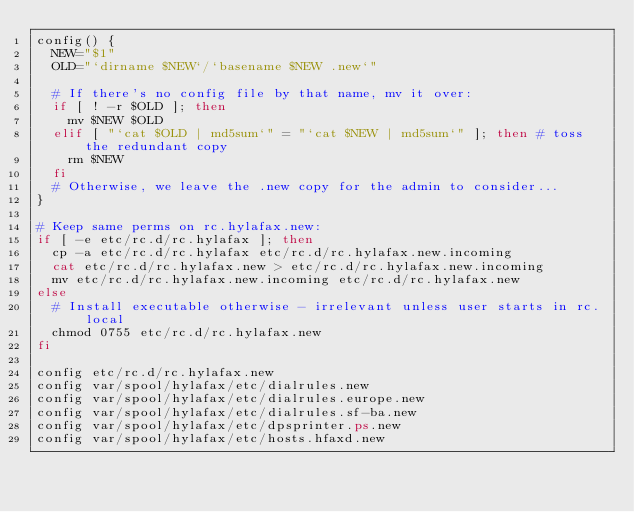<code> <loc_0><loc_0><loc_500><loc_500><_Bash_>config() {
  NEW="$1"
  OLD="`dirname $NEW`/`basename $NEW .new`"

  # If there's no config file by that name, mv it over:
  if [ ! -r $OLD ]; then
    mv $NEW $OLD
  elif [ "`cat $OLD | md5sum`" = "`cat $NEW | md5sum`" ]; then # toss the redundant copy
    rm $NEW
  fi
  # Otherwise, we leave the .new copy for the admin to consider...
}

# Keep same perms on rc.hylafax.new:
if [ -e etc/rc.d/rc.hylafax ]; then
  cp -a etc/rc.d/rc.hylafax etc/rc.d/rc.hylafax.new.incoming
  cat etc/rc.d/rc.hylafax.new > etc/rc.d/rc.hylafax.new.incoming
  mv etc/rc.d/rc.hylafax.new.incoming etc/rc.d/rc.hylafax.new
else
  # Install executable otherwise - irrelevant unless user starts in rc.local
  chmod 0755 etc/rc.d/rc.hylafax.new
fi

config etc/rc.d/rc.hylafax.new
config var/spool/hylafax/etc/dialrules.new
config var/spool/hylafax/etc/dialrules.europe.new
config var/spool/hylafax/etc/dialrules.sf-ba.new
config var/spool/hylafax/etc/dpsprinter.ps.new
config var/spool/hylafax/etc/hosts.hfaxd.new
</code> 